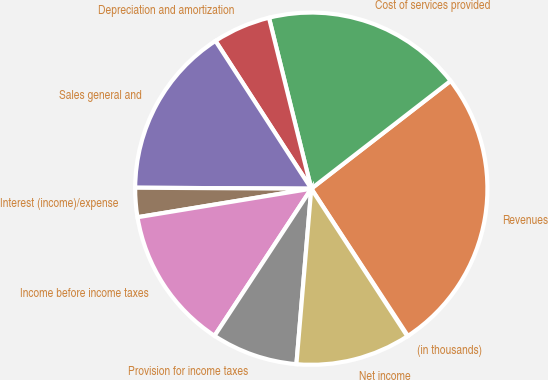<chart> <loc_0><loc_0><loc_500><loc_500><pie_chart><fcel>(in thousands)<fcel>Revenues<fcel>Cost of services provided<fcel>Depreciation and amortization<fcel>Sales general and<fcel>Interest (income)/expense<fcel>Income before income taxes<fcel>Provision for income taxes<fcel>Net income<nl><fcel>0.06%<fcel>26.24%<fcel>18.38%<fcel>5.29%<fcel>15.76%<fcel>2.68%<fcel>13.15%<fcel>7.91%<fcel>10.53%<nl></chart> 